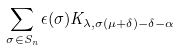Convert formula to latex. <formula><loc_0><loc_0><loc_500><loc_500>\sum _ { \sigma \in S _ { n } } \epsilon ( \sigma ) K _ { \lambda , \sigma ( \mu + \delta ) - \delta - \alpha }</formula> 